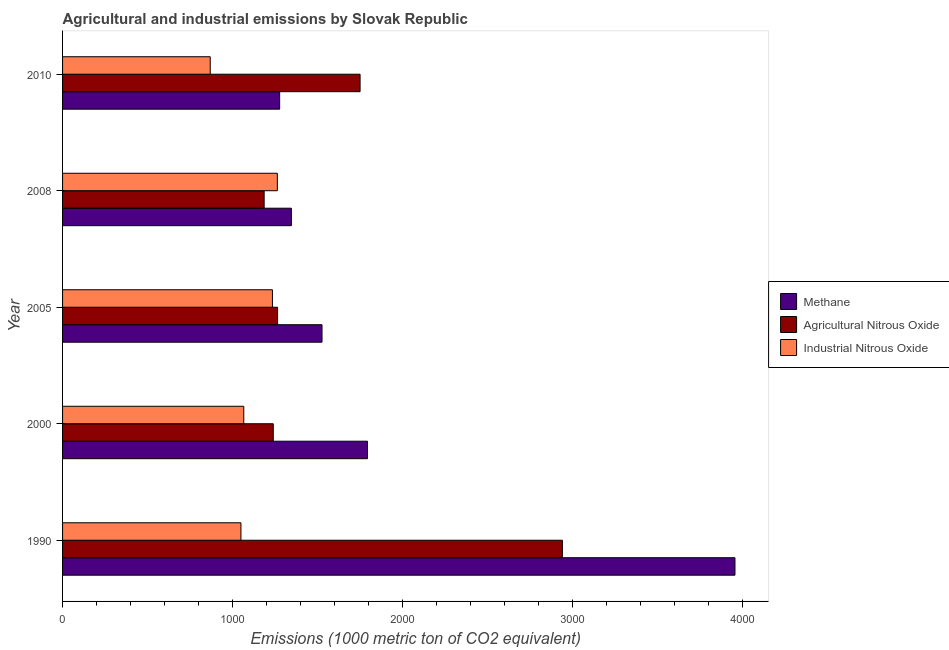How many different coloured bars are there?
Your response must be concise. 3. Are the number of bars per tick equal to the number of legend labels?
Provide a short and direct response. Yes. Are the number of bars on each tick of the Y-axis equal?
Make the answer very short. Yes. How many bars are there on the 3rd tick from the top?
Offer a very short reply. 3. What is the label of the 1st group of bars from the top?
Your answer should be very brief. 2010. What is the amount of agricultural nitrous oxide emissions in 2000?
Offer a very short reply. 1239.1. Across all years, what is the maximum amount of agricultural nitrous oxide emissions?
Provide a short and direct response. 2939.5. Across all years, what is the minimum amount of industrial nitrous oxide emissions?
Provide a succinct answer. 868.5. In which year was the amount of agricultural nitrous oxide emissions maximum?
Provide a short and direct response. 1990. In which year was the amount of agricultural nitrous oxide emissions minimum?
Your answer should be very brief. 2008. What is the total amount of industrial nitrous oxide emissions in the graph?
Your answer should be very brief. 5480.6. What is the difference between the amount of methane emissions in 1990 and that in 2010?
Give a very brief answer. 2677.8. What is the difference between the amount of industrial nitrous oxide emissions in 2000 and the amount of methane emissions in 2005?
Your answer should be compact. -460.2. What is the average amount of industrial nitrous oxide emissions per year?
Keep it short and to the point. 1096.12. In the year 2008, what is the difference between the amount of agricultural nitrous oxide emissions and amount of industrial nitrous oxide emissions?
Provide a short and direct response. -77.6. In how many years, is the amount of industrial nitrous oxide emissions greater than 3600 metric ton?
Make the answer very short. 0. What is the ratio of the amount of industrial nitrous oxide emissions in 2000 to that in 2005?
Offer a terse response. 0.86. What is the difference between the highest and the second highest amount of industrial nitrous oxide emissions?
Keep it short and to the point. 28.8. What is the difference between the highest and the lowest amount of methane emissions?
Keep it short and to the point. 2677.8. What does the 1st bar from the top in 2010 represents?
Provide a short and direct response. Industrial Nitrous Oxide. What does the 1st bar from the bottom in 2000 represents?
Ensure brevity in your answer.  Methane. Is it the case that in every year, the sum of the amount of methane emissions and amount of agricultural nitrous oxide emissions is greater than the amount of industrial nitrous oxide emissions?
Your response must be concise. Yes. How many bars are there?
Provide a short and direct response. 15. Are all the bars in the graph horizontal?
Offer a very short reply. Yes. What is the difference between two consecutive major ticks on the X-axis?
Provide a succinct answer. 1000. Does the graph contain grids?
Offer a very short reply. No. How many legend labels are there?
Offer a very short reply. 3. How are the legend labels stacked?
Your answer should be very brief. Vertical. What is the title of the graph?
Provide a succinct answer. Agricultural and industrial emissions by Slovak Republic. What is the label or title of the X-axis?
Give a very brief answer. Emissions (1000 metric ton of CO2 equivalent). What is the label or title of the Y-axis?
Keep it short and to the point. Year. What is the Emissions (1000 metric ton of CO2 equivalent) in Methane in 1990?
Ensure brevity in your answer.  3954.5. What is the Emissions (1000 metric ton of CO2 equivalent) in Agricultural Nitrous Oxide in 1990?
Your response must be concise. 2939.5. What is the Emissions (1000 metric ton of CO2 equivalent) in Industrial Nitrous Oxide in 1990?
Your response must be concise. 1049. What is the Emissions (1000 metric ton of CO2 equivalent) of Methane in 2000?
Provide a short and direct response. 1793.2. What is the Emissions (1000 metric ton of CO2 equivalent) of Agricultural Nitrous Oxide in 2000?
Provide a succinct answer. 1239.1. What is the Emissions (1000 metric ton of CO2 equivalent) in Industrial Nitrous Oxide in 2000?
Provide a short and direct response. 1065.7. What is the Emissions (1000 metric ton of CO2 equivalent) of Methane in 2005?
Ensure brevity in your answer.  1525.9. What is the Emissions (1000 metric ton of CO2 equivalent) of Agricultural Nitrous Oxide in 2005?
Provide a succinct answer. 1264.5. What is the Emissions (1000 metric ton of CO2 equivalent) in Industrial Nitrous Oxide in 2005?
Make the answer very short. 1234.3. What is the Emissions (1000 metric ton of CO2 equivalent) in Methane in 2008?
Provide a short and direct response. 1345.7. What is the Emissions (1000 metric ton of CO2 equivalent) in Agricultural Nitrous Oxide in 2008?
Offer a terse response. 1185.5. What is the Emissions (1000 metric ton of CO2 equivalent) of Industrial Nitrous Oxide in 2008?
Ensure brevity in your answer.  1263.1. What is the Emissions (1000 metric ton of CO2 equivalent) of Methane in 2010?
Your answer should be very brief. 1276.7. What is the Emissions (1000 metric ton of CO2 equivalent) of Agricultural Nitrous Oxide in 2010?
Offer a terse response. 1749.7. What is the Emissions (1000 metric ton of CO2 equivalent) of Industrial Nitrous Oxide in 2010?
Give a very brief answer. 868.5. Across all years, what is the maximum Emissions (1000 metric ton of CO2 equivalent) of Methane?
Your answer should be compact. 3954.5. Across all years, what is the maximum Emissions (1000 metric ton of CO2 equivalent) of Agricultural Nitrous Oxide?
Give a very brief answer. 2939.5. Across all years, what is the maximum Emissions (1000 metric ton of CO2 equivalent) in Industrial Nitrous Oxide?
Your answer should be compact. 1263.1. Across all years, what is the minimum Emissions (1000 metric ton of CO2 equivalent) of Methane?
Provide a short and direct response. 1276.7. Across all years, what is the minimum Emissions (1000 metric ton of CO2 equivalent) in Agricultural Nitrous Oxide?
Keep it short and to the point. 1185.5. Across all years, what is the minimum Emissions (1000 metric ton of CO2 equivalent) of Industrial Nitrous Oxide?
Offer a very short reply. 868.5. What is the total Emissions (1000 metric ton of CO2 equivalent) of Methane in the graph?
Ensure brevity in your answer.  9896. What is the total Emissions (1000 metric ton of CO2 equivalent) of Agricultural Nitrous Oxide in the graph?
Keep it short and to the point. 8378.3. What is the total Emissions (1000 metric ton of CO2 equivalent) of Industrial Nitrous Oxide in the graph?
Your answer should be very brief. 5480.6. What is the difference between the Emissions (1000 metric ton of CO2 equivalent) of Methane in 1990 and that in 2000?
Offer a terse response. 2161.3. What is the difference between the Emissions (1000 metric ton of CO2 equivalent) in Agricultural Nitrous Oxide in 1990 and that in 2000?
Ensure brevity in your answer.  1700.4. What is the difference between the Emissions (1000 metric ton of CO2 equivalent) in Industrial Nitrous Oxide in 1990 and that in 2000?
Provide a succinct answer. -16.7. What is the difference between the Emissions (1000 metric ton of CO2 equivalent) in Methane in 1990 and that in 2005?
Offer a very short reply. 2428.6. What is the difference between the Emissions (1000 metric ton of CO2 equivalent) of Agricultural Nitrous Oxide in 1990 and that in 2005?
Provide a short and direct response. 1675. What is the difference between the Emissions (1000 metric ton of CO2 equivalent) of Industrial Nitrous Oxide in 1990 and that in 2005?
Ensure brevity in your answer.  -185.3. What is the difference between the Emissions (1000 metric ton of CO2 equivalent) of Methane in 1990 and that in 2008?
Keep it short and to the point. 2608.8. What is the difference between the Emissions (1000 metric ton of CO2 equivalent) of Agricultural Nitrous Oxide in 1990 and that in 2008?
Give a very brief answer. 1754. What is the difference between the Emissions (1000 metric ton of CO2 equivalent) in Industrial Nitrous Oxide in 1990 and that in 2008?
Your response must be concise. -214.1. What is the difference between the Emissions (1000 metric ton of CO2 equivalent) of Methane in 1990 and that in 2010?
Offer a terse response. 2677.8. What is the difference between the Emissions (1000 metric ton of CO2 equivalent) of Agricultural Nitrous Oxide in 1990 and that in 2010?
Offer a terse response. 1189.8. What is the difference between the Emissions (1000 metric ton of CO2 equivalent) in Industrial Nitrous Oxide in 1990 and that in 2010?
Offer a terse response. 180.5. What is the difference between the Emissions (1000 metric ton of CO2 equivalent) of Methane in 2000 and that in 2005?
Your response must be concise. 267.3. What is the difference between the Emissions (1000 metric ton of CO2 equivalent) of Agricultural Nitrous Oxide in 2000 and that in 2005?
Make the answer very short. -25.4. What is the difference between the Emissions (1000 metric ton of CO2 equivalent) of Industrial Nitrous Oxide in 2000 and that in 2005?
Make the answer very short. -168.6. What is the difference between the Emissions (1000 metric ton of CO2 equivalent) in Methane in 2000 and that in 2008?
Provide a short and direct response. 447.5. What is the difference between the Emissions (1000 metric ton of CO2 equivalent) of Agricultural Nitrous Oxide in 2000 and that in 2008?
Ensure brevity in your answer.  53.6. What is the difference between the Emissions (1000 metric ton of CO2 equivalent) in Industrial Nitrous Oxide in 2000 and that in 2008?
Keep it short and to the point. -197.4. What is the difference between the Emissions (1000 metric ton of CO2 equivalent) of Methane in 2000 and that in 2010?
Ensure brevity in your answer.  516.5. What is the difference between the Emissions (1000 metric ton of CO2 equivalent) of Agricultural Nitrous Oxide in 2000 and that in 2010?
Ensure brevity in your answer.  -510.6. What is the difference between the Emissions (1000 metric ton of CO2 equivalent) in Industrial Nitrous Oxide in 2000 and that in 2010?
Give a very brief answer. 197.2. What is the difference between the Emissions (1000 metric ton of CO2 equivalent) of Methane in 2005 and that in 2008?
Give a very brief answer. 180.2. What is the difference between the Emissions (1000 metric ton of CO2 equivalent) in Agricultural Nitrous Oxide in 2005 and that in 2008?
Give a very brief answer. 79. What is the difference between the Emissions (1000 metric ton of CO2 equivalent) of Industrial Nitrous Oxide in 2005 and that in 2008?
Offer a very short reply. -28.8. What is the difference between the Emissions (1000 metric ton of CO2 equivalent) of Methane in 2005 and that in 2010?
Your response must be concise. 249.2. What is the difference between the Emissions (1000 metric ton of CO2 equivalent) in Agricultural Nitrous Oxide in 2005 and that in 2010?
Your response must be concise. -485.2. What is the difference between the Emissions (1000 metric ton of CO2 equivalent) in Industrial Nitrous Oxide in 2005 and that in 2010?
Provide a succinct answer. 365.8. What is the difference between the Emissions (1000 metric ton of CO2 equivalent) in Agricultural Nitrous Oxide in 2008 and that in 2010?
Provide a succinct answer. -564.2. What is the difference between the Emissions (1000 metric ton of CO2 equivalent) of Industrial Nitrous Oxide in 2008 and that in 2010?
Your response must be concise. 394.6. What is the difference between the Emissions (1000 metric ton of CO2 equivalent) of Methane in 1990 and the Emissions (1000 metric ton of CO2 equivalent) of Agricultural Nitrous Oxide in 2000?
Offer a very short reply. 2715.4. What is the difference between the Emissions (1000 metric ton of CO2 equivalent) of Methane in 1990 and the Emissions (1000 metric ton of CO2 equivalent) of Industrial Nitrous Oxide in 2000?
Provide a succinct answer. 2888.8. What is the difference between the Emissions (1000 metric ton of CO2 equivalent) of Agricultural Nitrous Oxide in 1990 and the Emissions (1000 metric ton of CO2 equivalent) of Industrial Nitrous Oxide in 2000?
Make the answer very short. 1873.8. What is the difference between the Emissions (1000 metric ton of CO2 equivalent) of Methane in 1990 and the Emissions (1000 metric ton of CO2 equivalent) of Agricultural Nitrous Oxide in 2005?
Offer a very short reply. 2690. What is the difference between the Emissions (1000 metric ton of CO2 equivalent) in Methane in 1990 and the Emissions (1000 metric ton of CO2 equivalent) in Industrial Nitrous Oxide in 2005?
Make the answer very short. 2720.2. What is the difference between the Emissions (1000 metric ton of CO2 equivalent) of Agricultural Nitrous Oxide in 1990 and the Emissions (1000 metric ton of CO2 equivalent) of Industrial Nitrous Oxide in 2005?
Make the answer very short. 1705.2. What is the difference between the Emissions (1000 metric ton of CO2 equivalent) in Methane in 1990 and the Emissions (1000 metric ton of CO2 equivalent) in Agricultural Nitrous Oxide in 2008?
Your answer should be compact. 2769. What is the difference between the Emissions (1000 metric ton of CO2 equivalent) in Methane in 1990 and the Emissions (1000 metric ton of CO2 equivalent) in Industrial Nitrous Oxide in 2008?
Provide a succinct answer. 2691.4. What is the difference between the Emissions (1000 metric ton of CO2 equivalent) in Agricultural Nitrous Oxide in 1990 and the Emissions (1000 metric ton of CO2 equivalent) in Industrial Nitrous Oxide in 2008?
Offer a very short reply. 1676.4. What is the difference between the Emissions (1000 metric ton of CO2 equivalent) in Methane in 1990 and the Emissions (1000 metric ton of CO2 equivalent) in Agricultural Nitrous Oxide in 2010?
Provide a short and direct response. 2204.8. What is the difference between the Emissions (1000 metric ton of CO2 equivalent) in Methane in 1990 and the Emissions (1000 metric ton of CO2 equivalent) in Industrial Nitrous Oxide in 2010?
Make the answer very short. 3086. What is the difference between the Emissions (1000 metric ton of CO2 equivalent) in Agricultural Nitrous Oxide in 1990 and the Emissions (1000 metric ton of CO2 equivalent) in Industrial Nitrous Oxide in 2010?
Your response must be concise. 2071. What is the difference between the Emissions (1000 metric ton of CO2 equivalent) of Methane in 2000 and the Emissions (1000 metric ton of CO2 equivalent) of Agricultural Nitrous Oxide in 2005?
Your response must be concise. 528.7. What is the difference between the Emissions (1000 metric ton of CO2 equivalent) in Methane in 2000 and the Emissions (1000 metric ton of CO2 equivalent) in Industrial Nitrous Oxide in 2005?
Your response must be concise. 558.9. What is the difference between the Emissions (1000 metric ton of CO2 equivalent) in Agricultural Nitrous Oxide in 2000 and the Emissions (1000 metric ton of CO2 equivalent) in Industrial Nitrous Oxide in 2005?
Make the answer very short. 4.8. What is the difference between the Emissions (1000 metric ton of CO2 equivalent) of Methane in 2000 and the Emissions (1000 metric ton of CO2 equivalent) of Agricultural Nitrous Oxide in 2008?
Your response must be concise. 607.7. What is the difference between the Emissions (1000 metric ton of CO2 equivalent) in Methane in 2000 and the Emissions (1000 metric ton of CO2 equivalent) in Industrial Nitrous Oxide in 2008?
Give a very brief answer. 530.1. What is the difference between the Emissions (1000 metric ton of CO2 equivalent) of Agricultural Nitrous Oxide in 2000 and the Emissions (1000 metric ton of CO2 equivalent) of Industrial Nitrous Oxide in 2008?
Offer a very short reply. -24. What is the difference between the Emissions (1000 metric ton of CO2 equivalent) of Methane in 2000 and the Emissions (1000 metric ton of CO2 equivalent) of Agricultural Nitrous Oxide in 2010?
Your answer should be very brief. 43.5. What is the difference between the Emissions (1000 metric ton of CO2 equivalent) in Methane in 2000 and the Emissions (1000 metric ton of CO2 equivalent) in Industrial Nitrous Oxide in 2010?
Your response must be concise. 924.7. What is the difference between the Emissions (1000 metric ton of CO2 equivalent) in Agricultural Nitrous Oxide in 2000 and the Emissions (1000 metric ton of CO2 equivalent) in Industrial Nitrous Oxide in 2010?
Give a very brief answer. 370.6. What is the difference between the Emissions (1000 metric ton of CO2 equivalent) of Methane in 2005 and the Emissions (1000 metric ton of CO2 equivalent) of Agricultural Nitrous Oxide in 2008?
Give a very brief answer. 340.4. What is the difference between the Emissions (1000 metric ton of CO2 equivalent) of Methane in 2005 and the Emissions (1000 metric ton of CO2 equivalent) of Industrial Nitrous Oxide in 2008?
Keep it short and to the point. 262.8. What is the difference between the Emissions (1000 metric ton of CO2 equivalent) of Methane in 2005 and the Emissions (1000 metric ton of CO2 equivalent) of Agricultural Nitrous Oxide in 2010?
Make the answer very short. -223.8. What is the difference between the Emissions (1000 metric ton of CO2 equivalent) of Methane in 2005 and the Emissions (1000 metric ton of CO2 equivalent) of Industrial Nitrous Oxide in 2010?
Offer a very short reply. 657.4. What is the difference between the Emissions (1000 metric ton of CO2 equivalent) of Agricultural Nitrous Oxide in 2005 and the Emissions (1000 metric ton of CO2 equivalent) of Industrial Nitrous Oxide in 2010?
Make the answer very short. 396. What is the difference between the Emissions (1000 metric ton of CO2 equivalent) in Methane in 2008 and the Emissions (1000 metric ton of CO2 equivalent) in Agricultural Nitrous Oxide in 2010?
Make the answer very short. -404. What is the difference between the Emissions (1000 metric ton of CO2 equivalent) of Methane in 2008 and the Emissions (1000 metric ton of CO2 equivalent) of Industrial Nitrous Oxide in 2010?
Offer a terse response. 477.2. What is the difference between the Emissions (1000 metric ton of CO2 equivalent) of Agricultural Nitrous Oxide in 2008 and the Emissions (1000 metric ton of CO2 equivalent) of Industrial Nitrous Oxide in 2010?
Your answer should be compact. 317. What is the average Emissions (1000 metric ton of CO2 equivalent) in Methane per year?
Provide a short and direct response. 1979.2. What is the average Emissions (1000 metric ton of CO2 equivalent) of Agricultural Nitrous Oxide per year?
Keep it short and to the point. 1675.66. What is the average Emissions (1000 metric ton of CO2 equivalent) in Industrial Nitrous Oxide per year?
Offer a very short reply. 1096.12. In the year 1990, what is the difference between the Emissions (1000 metric ton of CO2 equivalent) of Methane and Emissions (1000 metric ton of CO2 equivalent) of Agricultural Nitrous Oxide?
Your response must be concise. 1015. In the year 1990, what is the difference between the Emissions (1000 metric ton of CO2 equivalent) of Methane and Emissions (1000 metric ton of CO2 equivalent) of Industrial Nitrous Oxide?
Your response must be concise. 2905.5. In the year 1990, what is the difference between the Emissions (1000 metric ton of CO2 equivalent) in Agricultural Nitrous Oxide and Emissions (1000 metric ton of CO2 equivalent) in Industrial Nitrous Oxide?
Your answer should be very brief. 1890.5. In the year 2000, what is the difference between the Emissions (1000 metric ton of CO2 equivalent) in Methane and Emissions (1000 metric ton of CO2 equivalent) in Agricultural Nitrous Oxide?
Ensure brevity in your answer.  554.1. In the year 2000, what is the difference between the Emissions (1000 metric ton of CO2 equivalent) in Methane and Emissions (1000 metric ton of CO2 equivalent) in Industrial Nitrous Oxide?
Your answer should be compact. 727.5. In the year 2000, what is the difference between the Emissions (1000 metric ton of CO2 equivalent) of Agricultural Nitrous Oxide and Emissions (1000 metric ton of CO2 equivalent) of Industrial Nitrous Oxide?
Ensure brevity in your answer.  173.4. In the year 2005, what is the difference between the Emissions (1000 metric ton of CO2 equivalent) in Methane and Emissions (1000 metric ton of CO2 equivalent) in Agricultural Nitrous Oxide?
Your answer should be very brief. 261.4. In the year 2005, what is the difference between the Emissions (1000 metric ton of CO2 equivalent) of Methane and Emissions (1000 metric ton of CO2 equivalent) of Industrial Nitrous Oxide?
Provide a short and direct response. 291.6. In the year 2005, what is the difference between the Emissions (1000 metric ton of CO2 equivalent) of Agricultural Nitrous Oxide and Emissions (1000 metric ton of CO2 equivalent) of Industrial Nitrous Oxide?
Your answer should be compact. 30.2. In the year 2008, what is the difference between the Emissions (1000 metric ton of CO2 equivalent) of Methane and Emissions (1000 metric ton of CO2 equivalent) of Agricultural Nitrous Oxide?
Provide a succinct answer. 160.2. In the year 2008, what is the difference between the Emissions (1000 metric ton of CO2 equivalent) in Methane and Emissions (1000 metric ton of CO2 equivalent) in Industrial Nitrous Oxide?
Make the answer very short. 82.6. In the year 2008, what is the difference between the Emissions (1000 metric ton of CO2 equivalent) in Agricultural Nitrous Oxide and Emissions (1000 metric ton of CO2 equivalent) in Industrial Nitrous Oxide?
Your answer should be compact. -77.6. In the year 2010, what is the difference between the Emissions (1000 metric ton of CO2 equivalent) in Methane and Emissions (1000 metric ton of CO2 equivalent) in Agricultural Nitrous Oxide?
Your response must be concise. -473. In the year 2010, what is the difference between the Emissions (1000 metric ton of CO2 equivalent) of Methane and Emissions (1000 metric ton of CO2 equivalent) of Industrial Nitrous Oxide?
Offer a terse response. 408.2. In the year 2010, what is the difference between the Emissions (1000 metric ton of CO2 equivalent) in Agricultural Nitrous Oxide and Emissions (1000 metric ton of CO2 equivalent) in Industrial Nitrous Oxide?
Provide a succinct answer. 881.2. What is the ratio of the Emissions (1000 metric ton of CO2 equivalent) of Methane in 1990 to that in 2000?
Your response must be concise. 2.21. What is the ratio of the Emissions (1000 metric ton of CO2 equivalent) in Agricultural Nitrous Oxide in 1990 to that in 2000?
Offer a terse response. 2.37. What is the ratio of the Emissions (1000 metric ton of CO2 equivalent) of Industrial Nitrous Oxide in 1990 to that in 2000?
Your answer should be very brief. 0.98. What is the ratio of the Emissions (1000 metric ton of CO2 equivalent) of Methane in 1990 to that in 2005?
Give a very brief answer. 2.59. What is the ratio of the Emissions (1000 metric ton of CO2 equivalent) of Agricultural Nitrous Oxide in 1990 to that in 2005?
Your answer should be very brief. 2.32. What is the ratio of the Emissions (1000 metric ton of CO2 equivalent) of Industrial Nitrous Oxide in 1990 to that in 2005?
Give a very brief answer. 0.85. What is the ratio of the Emissions (1000 metric ton of CO2 equivalent) of Methane in 1990 to that in 2008?
Your response must be concise. 2.94. What is the ratio of the Emissions (1000 metric ton of CO2 equivalent) in Agricultural Nitrous Oxide in 1990 to that in 2008?
Your response must be concise. 2.48. What is the ratio of the Emissions (1000 metric ton of CO2 equivalent) of Industrial Nitrous Oxide in 1990 to that in 2008?
Ensure brevity in your answer.  0.83. What is the ratio of the Emissions (1000 metric ton of CO2 equivalent) of Methane in 1990 to that in 2010?
Your answer should be compact. 3.1. What is the ratio of the Emissions (1000 metric ton of CO2 equivalent) in Agricultural Nitrous Oxide in 1990 to that in 2010?
Ensure brevity in your answer.  1.68. What is the ratio of the Emissions (1000 metric ton of CO2 equivalent) of Industrial Nitrous Oxide in 1990 to that in 2010?
Provide a short and direct response. 1.21. What is the ratio of the Emissions (1000 metric ton of CO2 equivalent) in Methane in 2000 to that in 2005?
Your response must be concise. 1.18. What is the ratio of the Emissions (1000 metric ton of CO2 equivalent) in Agricultural Nitrous Oxide in 2000 to that in 2005?
Your response must be concise. 0.98. What is the ratio of the Emissions (1000 metric ton of CO2 equivalent) of Industrial Nitrous Oxide in 2000 to that in 2005?
Ensure brevity in your answer.  0.86. What is the ratio of the Emissions (1000 metric ton of CO2 equivalent) in Methane in 2000 to that in 2008?
Your answer should be compact. 1.33. What is the ratio of the Emissions (1000 metric ton of CO2 equivalent) in Agricultural Nitrous Oxide in 2000 to that in 2008?
Offer a terse response. 1.05. What is the ratio of the Emissions (1000 metric ton of CO2 equivalent) in Industrial Nitrous Oxide in 2000 to that in 2008?
Your answer should be compact. 0.84. What is the ratio of the Emissions (1000 metric ton of CO2 equivalent) in Methane in 2000 to that in 2010?
Keep it short and to the point. 1.4. What is the ratio of the Emissions (1000 metric ton of CO2 equivalent) in Agricultural Nitrous Oxide in 2000 to that in 2010?
Offer a terse response. 0.71. What is the ratio of the Emissions (1000 metric ton of CO2 equivalent) in Industrial Nitrous Oxide in 2000 to that in 2010?
Your answer should be very brief. 1.23. What is the ratio of the Emissions (1000 metric ton of CO2 equivalent) in Methane in 2005 to that in 2008?
Ensure brevity in your answer.  1.13. What is the ratio of the Emissions (1000 metric ton of CO2 equivalent) of Agricultural Nitrous Oxide in 2005 to that in 2008?
Give a very brief answer. 1.07. What is the ratio of the Emissions (1000 metric ton of CO2 equivalent) of Industrial Nitrous Oxide in 2005 to that in 2008?
Your answer should be very brief. 0.98. What is the ratio of the Emissions (1000 metric ton of CO2 equivalent) of Methane in 2005 to that in 2010?
Your answer should be compact. 1.2. What is the ratio of the Emissions (1000 metric ton of CO2 equivalent) in Agricultural Nitrous Oxide in 2005 to that in 2010?
Your answer should be very brief. 0.72. What is the ratio of the Emissions (1000 metric ton of CO2 equivalent) of Industrial Nitrous Oxide in 2005 to that in 2010?
Your response must be concise. 1.42. What is the ratio of the Emissions (1000 metric ton of CO2 equivalent) in Methane in 2008 to that in 2010?
Offer a very short reply. 1.05. What is the ratio of the Emissions (1000 metric ton of CO2 equivalent) of Agricultural Nitrous Oxide in 2008 to that in 2010?
Provide a short and direct response. 0.68. What is the ratio of the Emissions (1000 metric ton of CO2 equivalent) of Industrial Nitrous Oxide in 2008 to that in 2010?
Make the answer very short. 1.45. What is the difference between the highest and the second highest Emissions (1000 metric ton of CO2 equivalent) of Methane?
Offer a very short reply. 2161.3. What is the difference between the highest and the second highest Emissions (1000 metric ton of CO2 equivalent) in Agricultural Nitrous Oxide?
Offer a terse response. 1189.8. What is the difference between the highest and the second highest Emissions (1000 metric ton of CO2 equivalent) of Industrial Nitrous Oxide?
Provide a succinct answer. 28.8. What is the difference between the highest and the lowest Emissions (1000 metric ton of CO2 equivalent) of Methane?
Offer a terse response. 2677.8. What is the difference between the highest and the lowest Emissions (1000 metric ton of CO2 equivalent) in Agricultural Nitrous Oxide?
Offer a very short reply. 1754. What is the difference between the highest and the lowest Emissions (1000 metric ton of CO2 equivalent) in Industrial Nitrous Oxide?
Offer a very short reply. 394.6. 